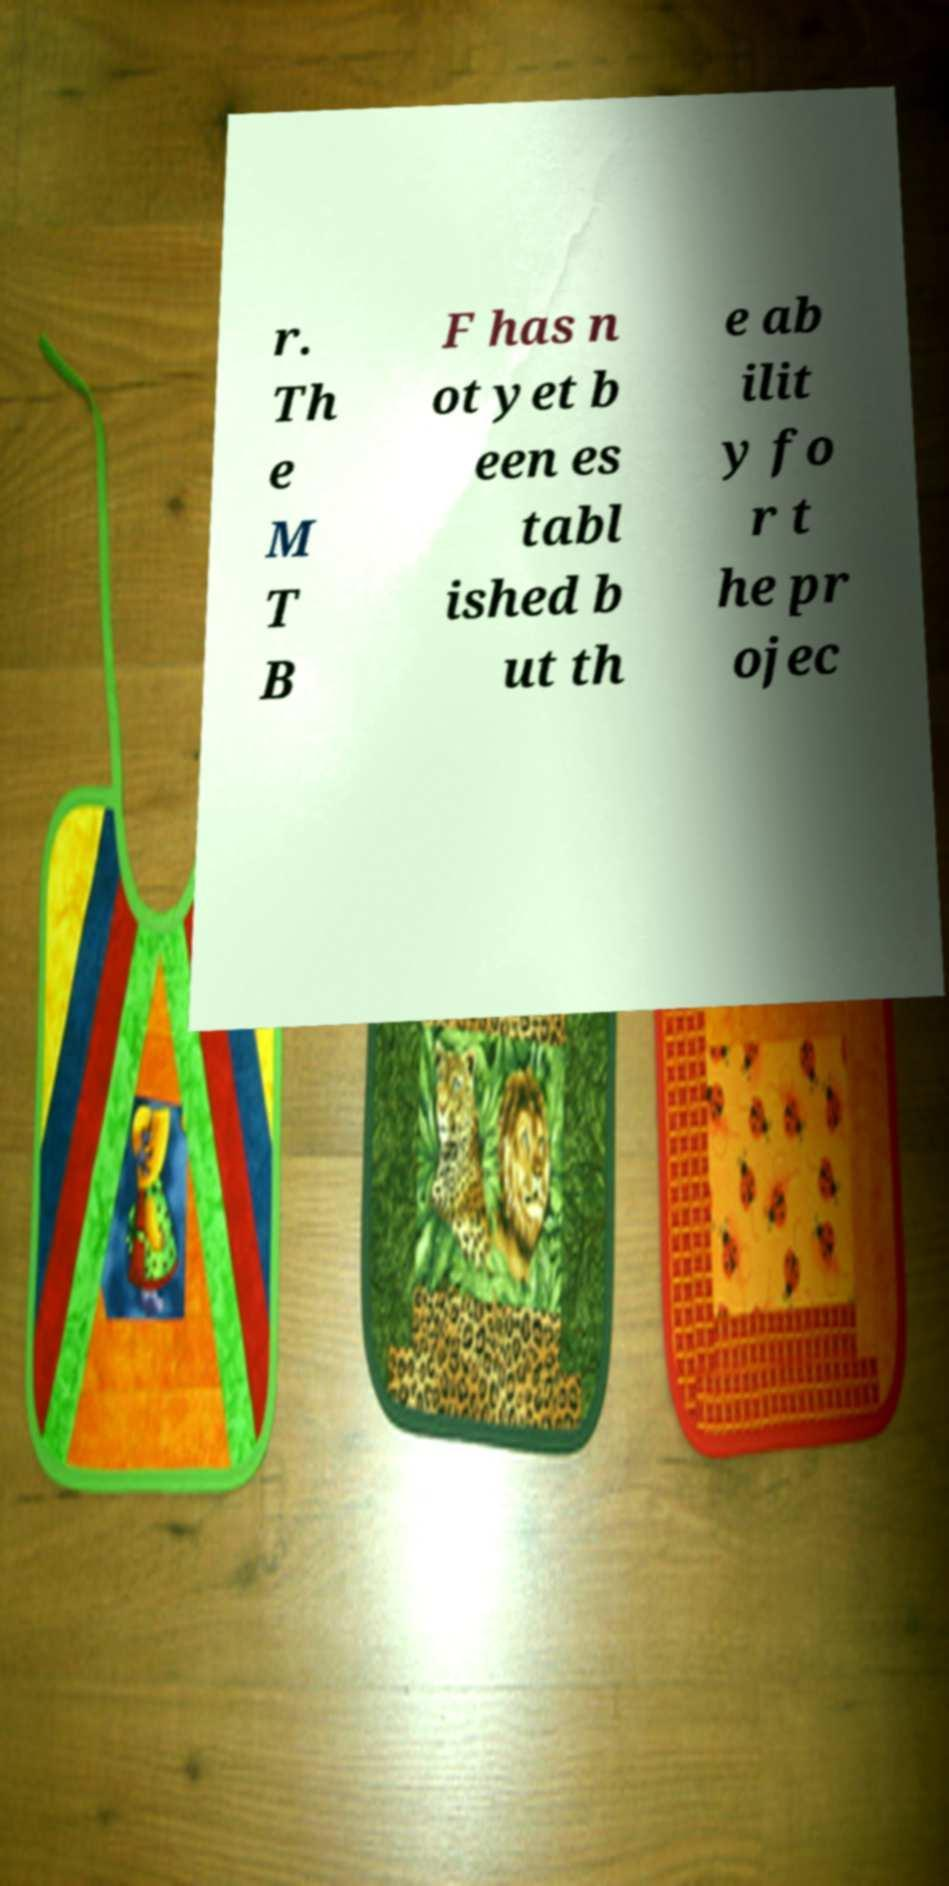Can you accurately transcribe the text from the provided image for me? r. Th e M T B F has n ot yet b een es tabl ished b ut th e ab ilit y fo r t he pr ojec 